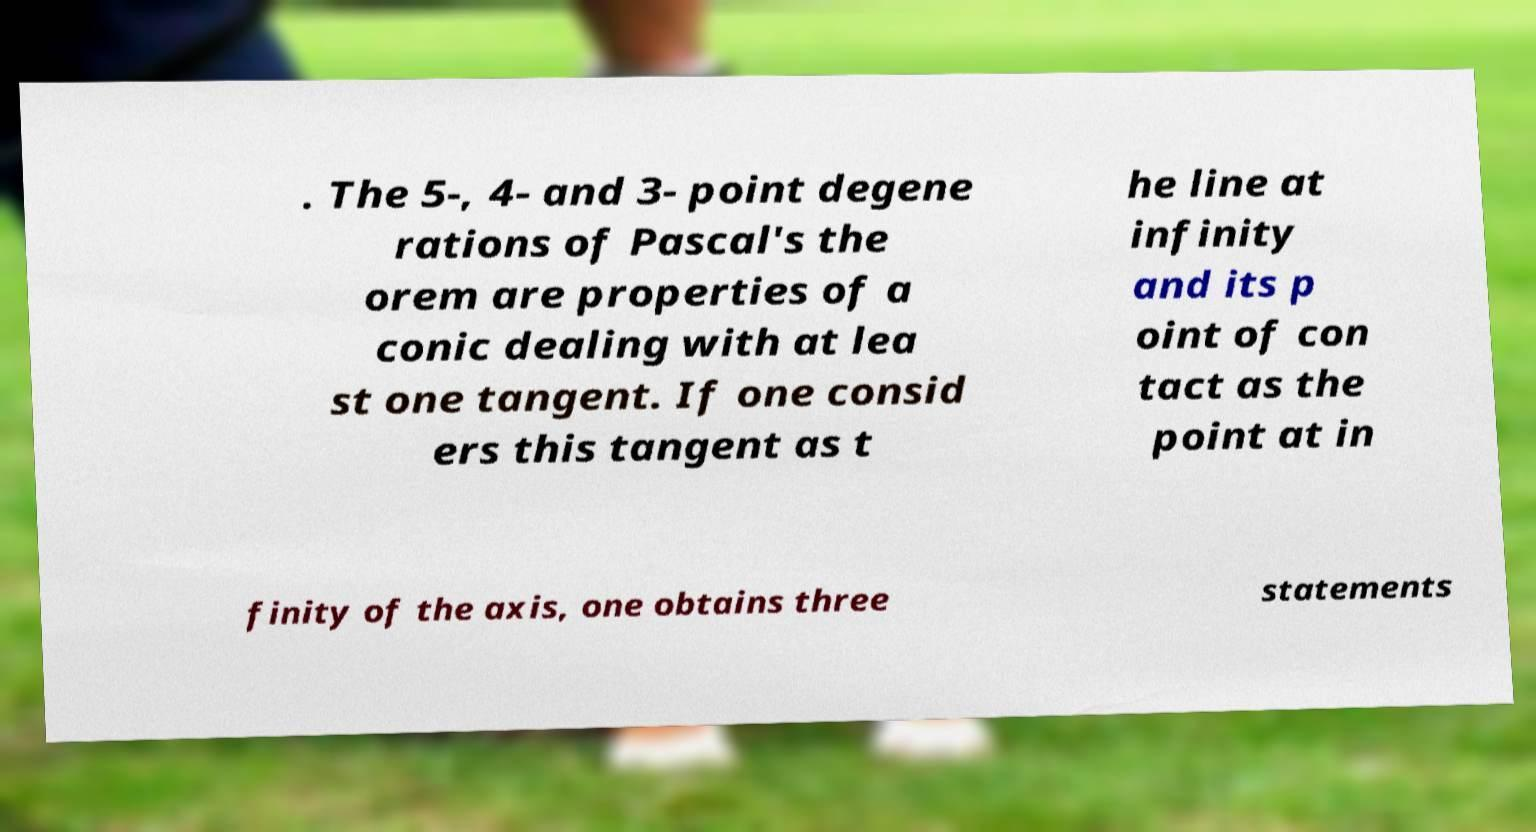Can you accurately transcribe the text from the provided image for me? . The 5-, 4- and 3- point degene rations of Pascal's the orem are properties of a conic dealing with at lea st one tangent. If one consid ers this tangent as t he line at infinity and its p oint of con tact as the point at in finity of the axis, one obtains three statements 